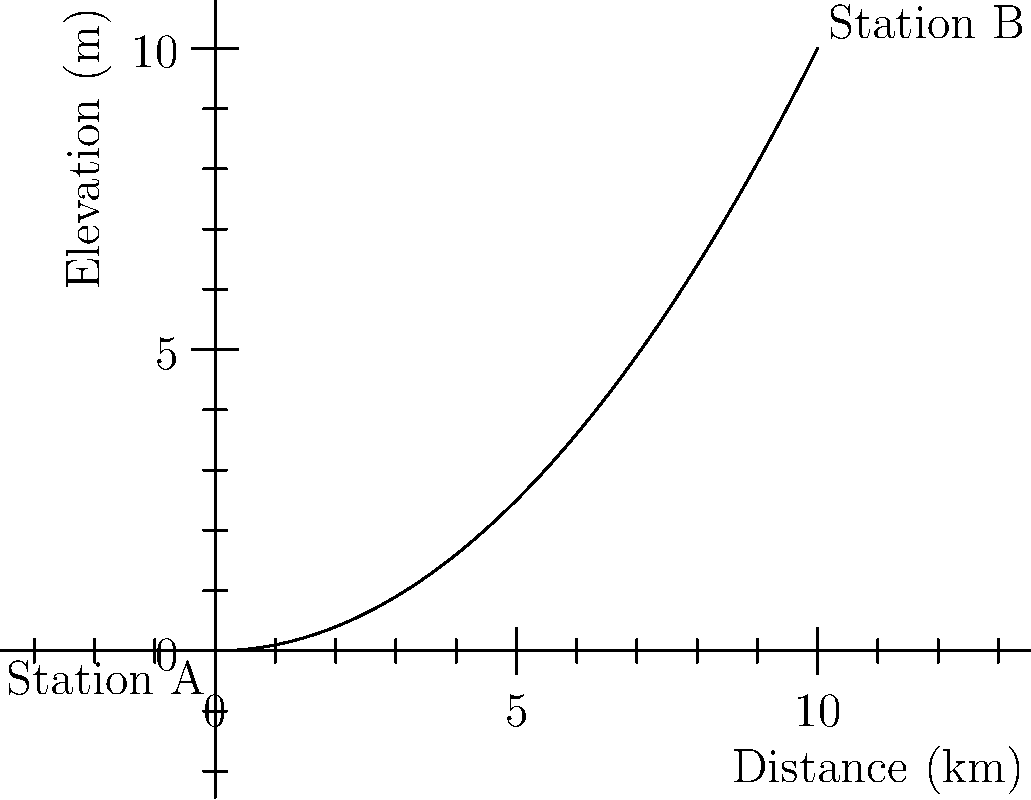Based on the subway line profile graph shown, estimate the travel time between Station A and Station B if the train maintains an average speed of 60 km/h. Assume the train's speed is not affected by the elevation change. To estimate the travel time, we need to follow these steps:

1. Determine the distance between stations:
   The x-axis represents distance, and Station B is at x = 10 km.

2. Calculate travel time using the formula:
   $$ \text{Time} = \frac{\text{Distance}}{\text{Speed}} $$

3. Convert the speed from km/h to km/min for easier calculation:
   $$ 60 \text{ km/h} = 1 \text{ km/min} $$

4. Apply the formula:
   $$ \text{Time} = \frac{10 \text{ km}}{1 \text{ km/min}} = 10 \text{ minutes} $$

Note: The elevation change shown in the graph does not affect the travel time in this scenario, as we assumed the train's speed is not affected by elevation.
Answer: 10 minutes 